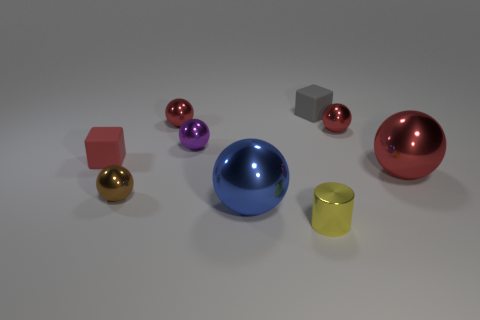Is there a tiny purple shiny thing that is to the right of the rubber block that is on the left side of the big blue metallic object?
Provide a succinct answer. Yes. There is a small metallic sphere that is in front of the matte block in front of the purple object; how many small purple shiny things are in front of it?
Offer a terse response. 0. The ball that is both behind the red cube and on the right side of the gray matte thing is what color?
Offer a terse response. Red. What number of cubes are tiny yellow objects or small matte objects?
Make the answer very short. 2. What is the color of the metallic cylinder that is the same size as the purple ball?
Make the answer very short. Yellow. There is a small rubber thing that is behind the red shiny sphere that is to the left of the tiny gray rubber block; are there any tiny metal things that are on the right side of it?
Give a very brief answer. Yes. What is the size of the blue ball?
Your answer should be very brief. Large. How many objects are small purple blocks or large blue balls?
Make the answer very short. 1. There is a small cylinder that is made of the same material as the tiny purple ball; what is its color?
Keep it short and to the point. Yellow. Is the shape of the small matte object left of the large blue ball the same as  the gray thing?
Your answer should be compact. Yes. 